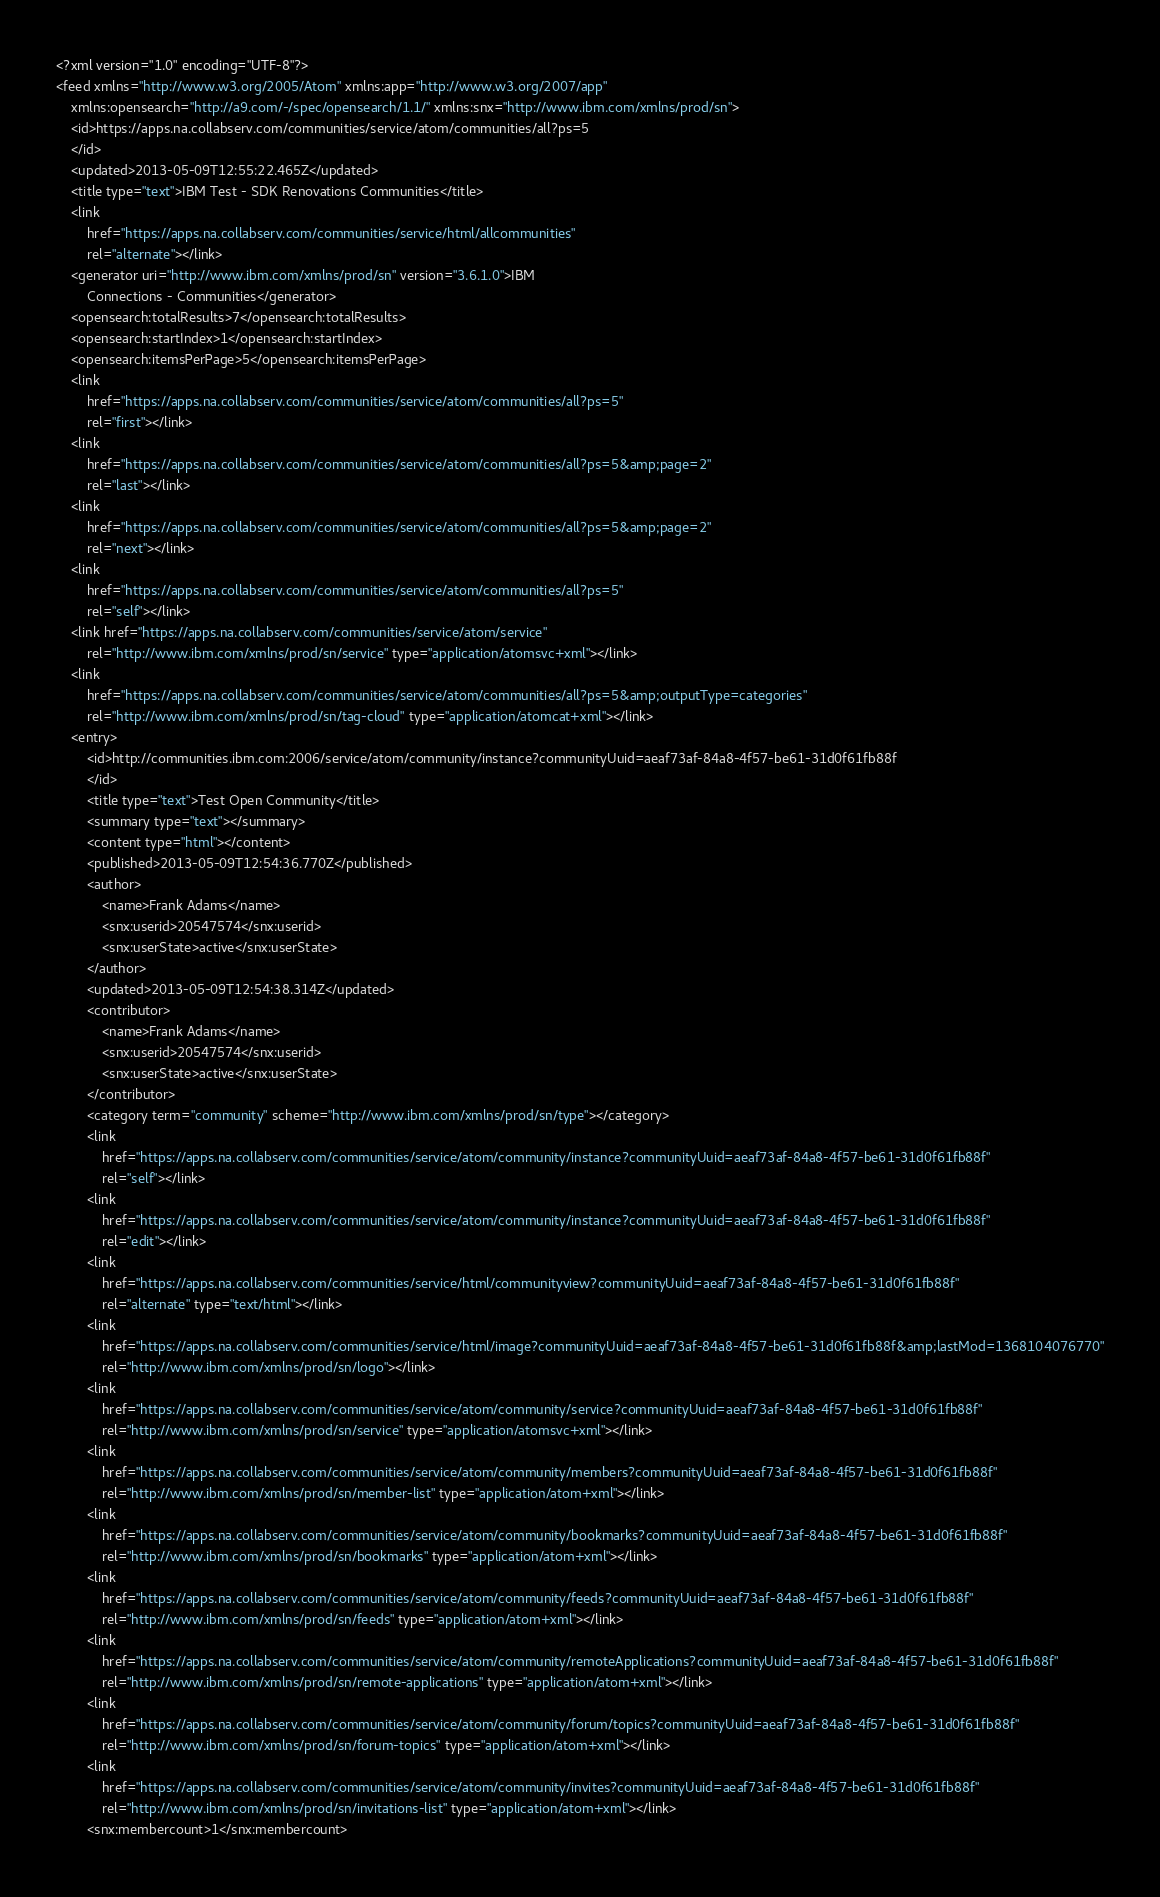<code> <loc_0><loc_0><loc_500><loc_500><_XML_><?xml version="1.0" encoding="UTF-8"?>
<feed xmlns="http://www.w3.org/2005/Atom" xmlns:app="http://www.w3.org/2007/app"
	xmlns:opensearch="http://a9.com/-/spec/opensearch/1.1/" xmlns:snx="http://www.ibm.com/xmlns/prod/sn">
	<id>https://apps.na.collabserv.com/communities/service/atom/communities/all?ps=5
	</id>
	<updated>2013-05-09T12:55:22.465Z</updated>
	<title type="text">IBM Test - SDK Renovations Communities</title>
	<link
		href="https://apps.na.collabserv.com/communities/service/html/allcommunities"
		rel="alternate"></link>
	<generator uri="http://www.ibm.com/xmlns/prod/sn" version="3.6.1.0">IBM
		Connections - Communities</generator>
	<opensearch:totalResults>7</opensearch:totalResults>
	<opensearch:startIndex>1</opensearch:startIndex>
	<opensearch:itemsPerPage>5</opensearch:itemsPerPage>
	<link
		href="https://apps.na.collabserv.com/communities/service/atom/communities/all?ps=5"
		rel="first"></link>
	<link
		href="https://apps.na.collabserv.com/communities/service/atom/communities/all?ps=5&amp;page=2"
		rel="last"></link>
	<link
		href="https://apps.na.collabserv.com/communities/service/atom/communities/all?ps=5&amp;page=2"
		rel="next"></link>
	<link
		href="https://apps.na.collabserv.com/communities/service/atom/communities/all?ps=5"
		rel="self"></link>
	<link href="https://apps.na.collabserv.com/communities/service/atom/service"
		rel="http://www.ibm.com/xmlns/prod/sn/service" type="application/atomsvc+xml"></link>
	<link
		href="https://apps.na.collabserv.com/communities/service/atom/communities/all?ps=5&amp;outputType=categories"
		rel="http://www.ibm.com/xmlns/prod/sn/tag-cloud" type="application/atomcat+xml"></link>
	<entry>
		<id>http://communities.ibm.com:2006/service/atom/community/instance?communityUuid=aeaf73af-84a8-4f57-be61-31d0f61fb88f
		</id>
		<title type="text">Test Open Community</title>
		<summary type="text"></summary>
		<content type="html"></content>
		<published>2013-05-09T12:54:36.770Z</published>
		<author>
			<name>Frank Adams</name>
			<snx:userid>20547574</snx:userid>
			<snx:userState>active</snx:userState>
		</author>
		<updated>2013-05-09T12:54:38.314Z</updated>
		<contributor>
			<name>Frank Adams</name>
			<snx:userid>20547574</snx:userid>
			<snx:userState>active</snx:userState>
		</contributor>
		<category term="community" scheme="http://www.ibm.com/xmlns/prod/sn/type"></category>
		<link
			href="https://apps.na.collabserv.com/communities/service/atom/community/instance?communityUuid=aeaf73af-84a8-4f57-be61-31d0f61fb88f"
			rel="self"></link>
		<link
			href="https://apps.na.collabserv.com/communities/service/atom/community/instance?communityUuid=aeaf73af-84a8-4f57-be61-31d0f61fb88f"
			rel="edit"></link>
		<link
			href="https://apps.na.collabserv.com/communities/service/html/communityview?communityUuid=aeaf73af-84a8-4f57-be61-31d0f61fb88f"
			rel="alternate" type="text/html"></link>
		<link
			href="https://apps.na.collabserv.com/communities/service/html/image?communityUuid=aeaf73af-84a8-4f57-be61-31d0f61fb88f&amp;lastMod=1368104076770"
			rel="http://www.ibm.com/xmlns/prod/sn/logo"></link>
		<link
			href="https://apps.na.collabserv.com/communities/service/atom/community/service?communityUuid=aeaf73af-84a8-4f57-be61-31d0f61fb88f"
			rel="http://www.ibm.com/xmlns/prod/sn/service" type="application/atomsvc+xml"></link>
		<link
			href="https://apps.na.collabserv.com/communities/service/atom/community/members?communityUuid=aeaf73af-84a8-4f57-be61-31d0f61fb88f"
			rel="http://www.ibm.com/xmlns/prod/sn/member-list" type="application/atom+xml"></link>
		<link
			href="https://apps.na.collabserv.com/communities/service/atom/community/bookmarks?communityUuid=aeaf73af-84a8-4f57-be61-31d0f61fb88f"
			rel="http://www.ibm.com/xmlns/prod/sn/bookmarks" type="application/atom+xml"></link>
		<link
			href="https://apps.na.collabserv.com/communities/service/atom/community/feeds?communityUuid=aeaf73af-84a8-4f57-be61-31d0f61fb88f"
			rel="http://www.ibm.com/xmlns/prod/sn/feeds" type="application/atom+xml"></link>
		<link
			href="https://apps.na.collabserv.com/communities/service/atom/community/remoteApplications?communityUuid=aeaf73af-84a8-4f57-be61-31d0f61fb88f"
			rel="http://www.ibm.com/xmlns/prod/sn/remote-applications" type="application/atom+xml"></link>
		<link
			href="https://apps.na.collabserv.com/communities/service/atom/community/forum/topics?communityUuid=aeaf73af-84a8-4f57-be61-31d0f61fb88f"
			rel="http://www.ibm.com/xmlns/prod/sn/forum-topics" type="application/atom+xml"></link>
		<link
			href="https://apps.na.collabserv.com/communities/service/atom/community/invites?communityUuid=aeaf73af-84a8-4f57-be61-31d0f61fb88f"
			rel="http://www.ibm.com/xmlns/prod/sn/invitations-list" type="application/atom+xml"></link>
		<snx:membercount>1</snx:membercount></code> 